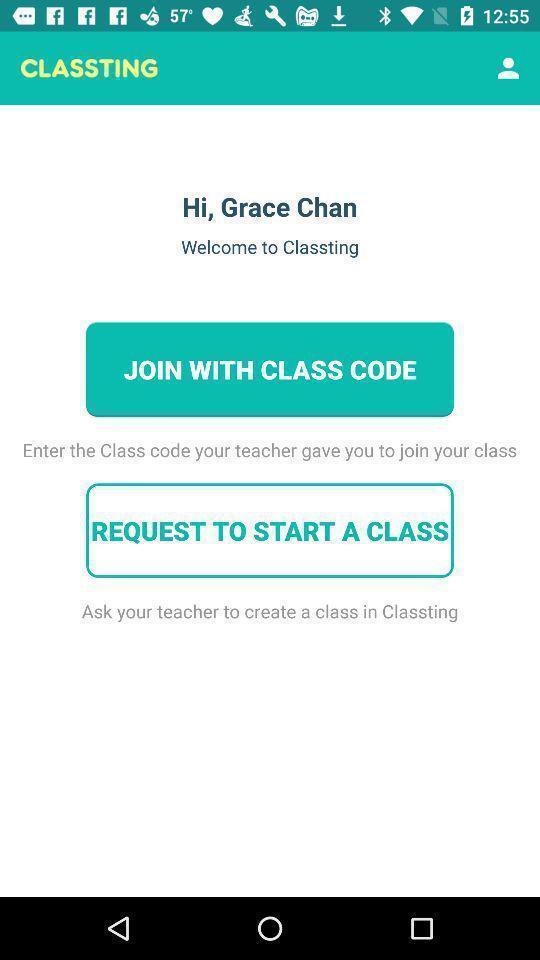Describe the content in this image. Welcome to classting of join with class code. 